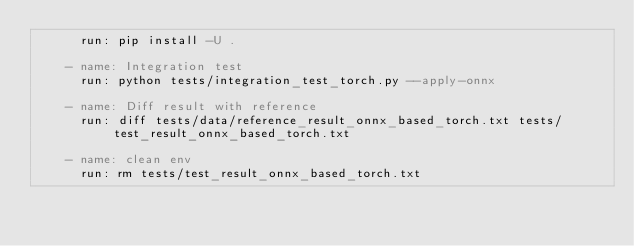<code> <loc_0><loc_0><loc_500><loc_500><_YAML_>      run: pip install -U .

    - name: Integration test
      run: python tests/integration_test_torch.py --apply-onnx
    
    - name: Diff result with reference
      run: diff tests/data/reference_result_onnx_based_torch.txt tests/test_result_onnx_based_torch.txt

    - name: clean env
      run: rm tests/test_result_onnx_based_torch.txt
</code> 